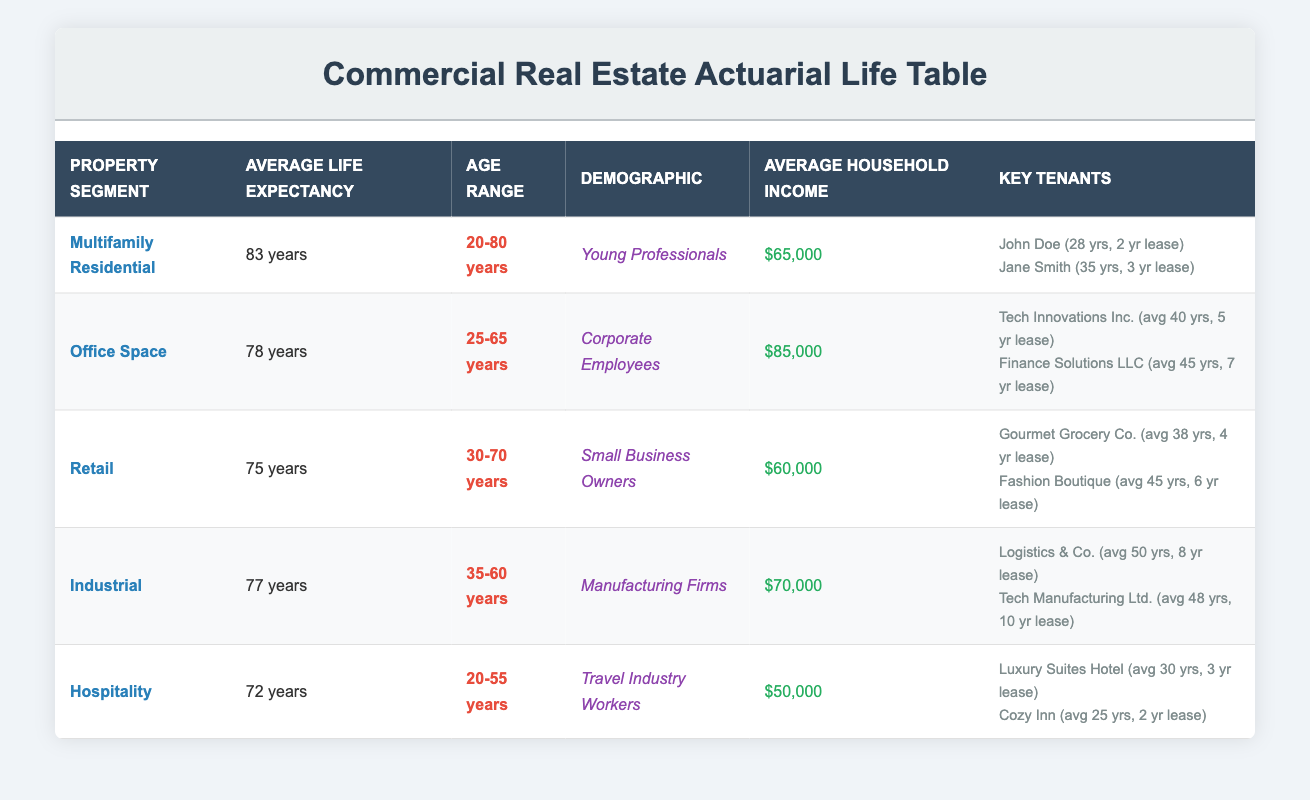What is the average life expectancy for tenants in Multifamily Residential properties? From the table, the average life expectancy for tenants in the Multifamily Residential segment is listed as 83 years.
Answer: 83 years How many years of lease duration does Tech Innovations Inc. have? According to the table, Tech Innovations Inc. has a duration of lease of 5 years.
Answer: 5 years Which property segment has the lowest average life expectancy? The Retail segment has the lowest average life expectancy, which is 75 years, compared to the others listed.
Answer: Retail What is the age range for tenants in the Office Space segment? The age range for tenants in the Office Space segment is provided as 25 to 65 years.
Answer: 25-65 years How many key tenants are there in the Industrial property segment? The table shows 2 key tenants listed for the Industrial property segment: Logistics & Co. and Tech Manufacturing Ltd.
Answer: 2 key tenants Is the average household income higher in the Office Space segment compared to Hospitality? Yes, the average household income in the Office Space segment is $85,000, while in the Hospitality segment it is $50,000, making it higher.
Answer: Yes What is the average life expectancy of tenants in the Hospitality segment? The average life expectancy for tenants in the Hospitality segment is listed as 72 years.
Answer: 72 years If we average the life expectancies of the Office Space and Industrial segments, what do we get? The average life expectancy for Office Space is 78 years, and for Industrial, it is 77 years. Adding these gives 155 years, and averaging them (155/2) results in an average of 77.5 years.
Answer: 77.5 years What demographic is associated with the Multifamily Residential property segment? The demographic associated with the Multifamily Residential segment is described as Young Professionals according to the table.
Answer: Young Professionals How does the average household income in the Retail segment compare to the average household income in the Industrial segment? The average household income in Retail is $60,000, and in Industrial, it is $70,000. Since $60,000 is less than $70,000, it is lower.
Answer: Retail is lower than Industrial 